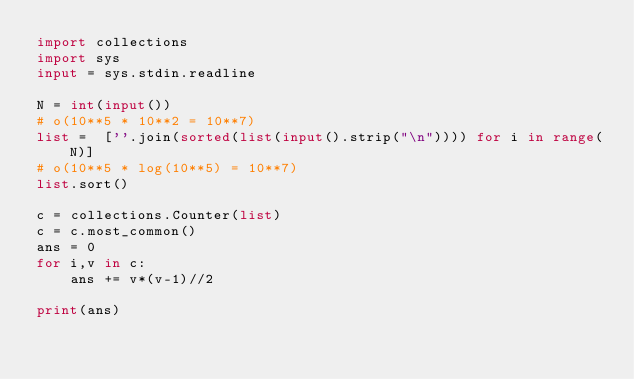<code> <loc_0><loc_0><loc_500><loc_500><_Python_>import collections
import sys
input = sys.stdin.readline

N = int(input())
# o(10**5 * 10**2 = 10**7)
list =  [''.join(sorted(list(input().strip("\n")))) for i in range(N)]
# o(10**5 * log(10**5) = 10**7)
list.sort()

c = collections.Counter(list)
c = c.most_common()
ans = 0
for i,v in c:
    ans += v*(v-1)//2

print(ans)</code> 